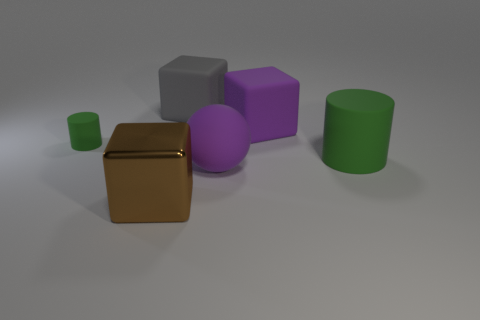There is another rubber object that is the same shape as the large green rubber object; what is its color?
Provide a succinct answer. Green. Are there an equal number of metallic things on the left side of the large green rubber thing and gray things?
Offer a very short reply. Yes. How many blocks are purple objects or large metallic things?
Provide a short and direct response. 2. There is a sphere that is made of the same material as the large green thing; what is its color?
Offer a very short reply. Purple. Are the big purple ball and the green object left of the large green object made of the same material?
Ensure brevity in your answer.  Yes. How many objects are small cyan shiny things or big gray cubes?
Your response must be concise. 1. What is the material of the other cylinder that is the same color as the tiny cylinder?
Offer a very short reply. Rubber. Are there any big objects that have the same shape as the tiny green object?
Provide a short and direct response. Yes. How many big brown objects are behind the small matte cylinder?
Your answer should be very brief. 0. What is the material of the large purple thing that is behind the cylinder that is in front of the small cylinder?
Provide a succinct answer. Rubber. 